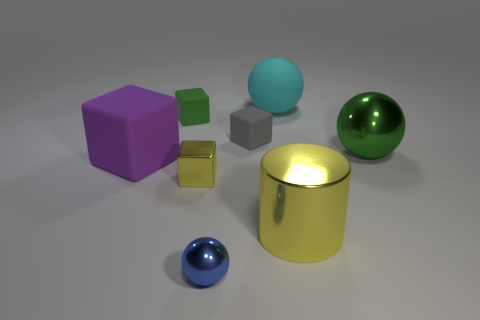Add 1 large brown rubber cubes. How many objects exist? 9 Subtract all spheres. How many objects are left? 5 Add 1 large green balls. How many large green balls are left? 2 Add 2 blue balls. How many blue balls exist? 3 Subtract 0 green cylinders. How many objects are left? 8 Subtract all small gray shiny cubes. Subtract all big purple things. How many objects are left? 7 